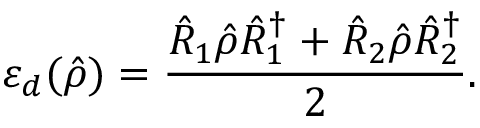<formula> <loc_0><loc_0><loc_500><loc_500>\varepsilon _ { d } ( \hat { \rho } ) = \frac { \hat { R } _ { 1 } \hat { \rho } \hat { R } _ { 1 } ^ { \dagger } + \hat { R } _ { 2 } \hat { \rho } \hat { R } _ { 2 } ^ { \dagger } } { 2 } .</formula> 